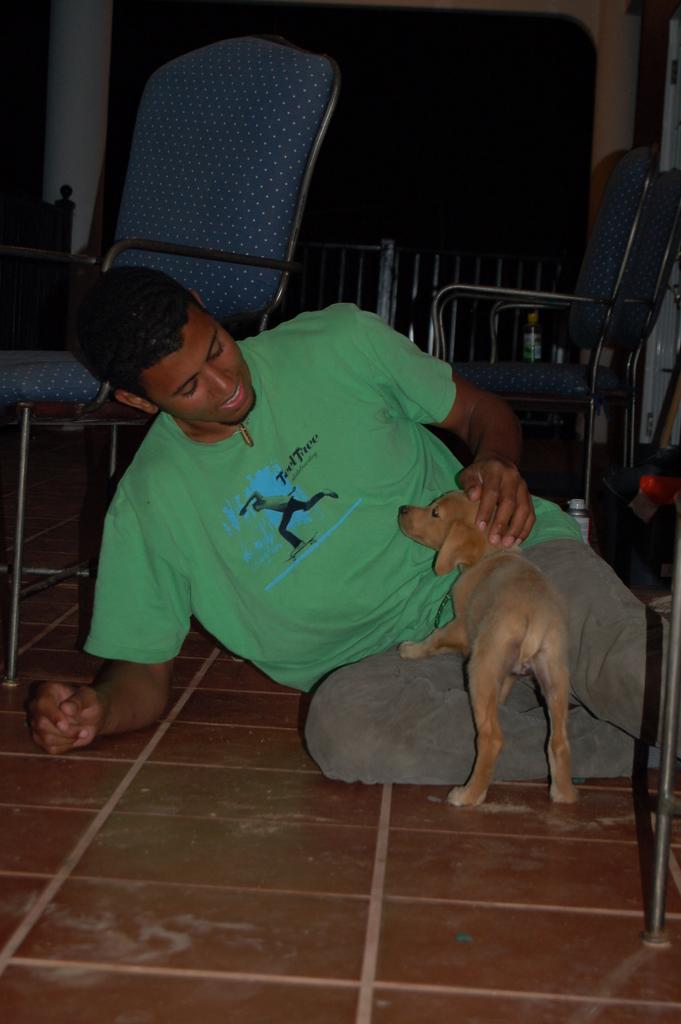What is the man in the image doing? The man is sitting on the floor. What other living creature is present in the image? There is a dog in the image. Are there any furniture items visible in the image? Yes, there are chairs in the image. How does the man show his interest in the dog's friend in the image? There is no mention of a dog's friend in the image, so it is not possible to answer this question. 